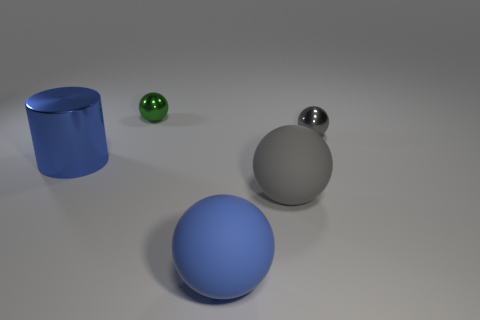Subtract 2 balls. How many balls are left? 2 Subtract all green spheres. How many spheres are left? 3 Subtract all green balls. How many balls are left? 3 Subtract all cyan spheres. Subtract all red cylinders. How many spheres are left? 4 Add 4 big gray spheres. How many objects exist? 9 Subtract all cylinders. How many objects are left? 4 Add 5 large purple objects. How many large purple objects exist? 5 Subtract 1 blue cylinders. How many objects are left? 4 Subtract all purple spheres. Subtract all gray balls. How many objects are left? 3 Add 4 metal things. How many metal things are left? 7 